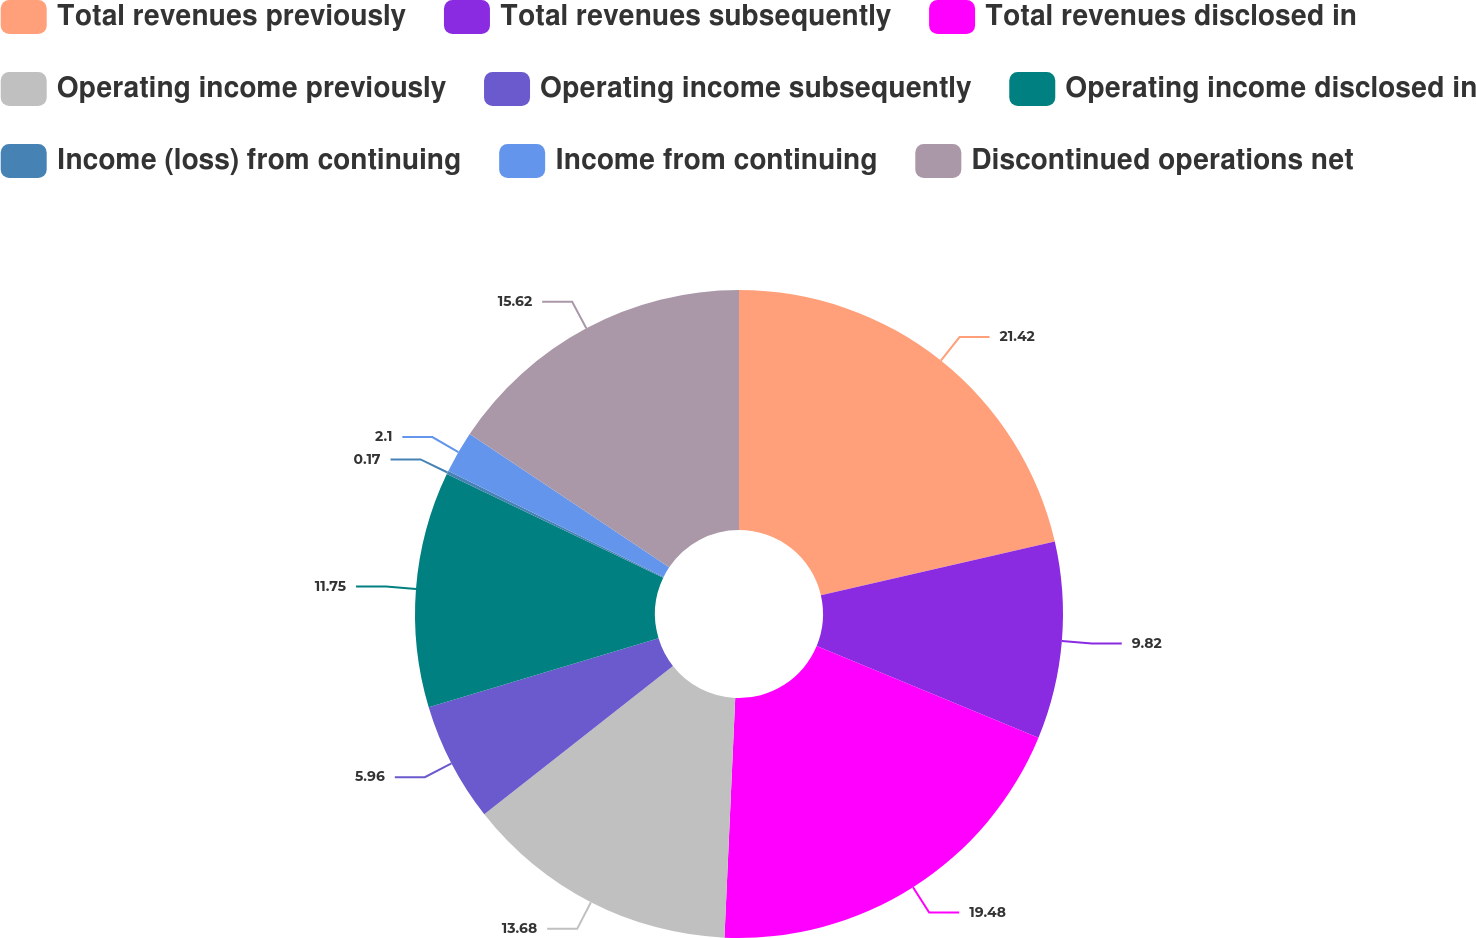Convert chart. <chart><loc_0><loc_0><loc_500><loc_500><pie_chart><fcel>Total revenues previously<fcel>Total revenues subsequently<fcel>Total revenues disclosed in<fcel>Operating income previously<fcel>Operating income subsequently<fcel>Operating income disclosed in<fcel>Income (loss) from continuing<fcel>Income from continuing<fcel>Discontinued operations net<nl><fcel>21.41%<fcel>9.82%<fcel>19.48%<fcel>13.68%<fcel>5.96%<fcel>11.75%<fcel>0.17%<fcel>2.1%<fcel>15.62%<nl></chart> 